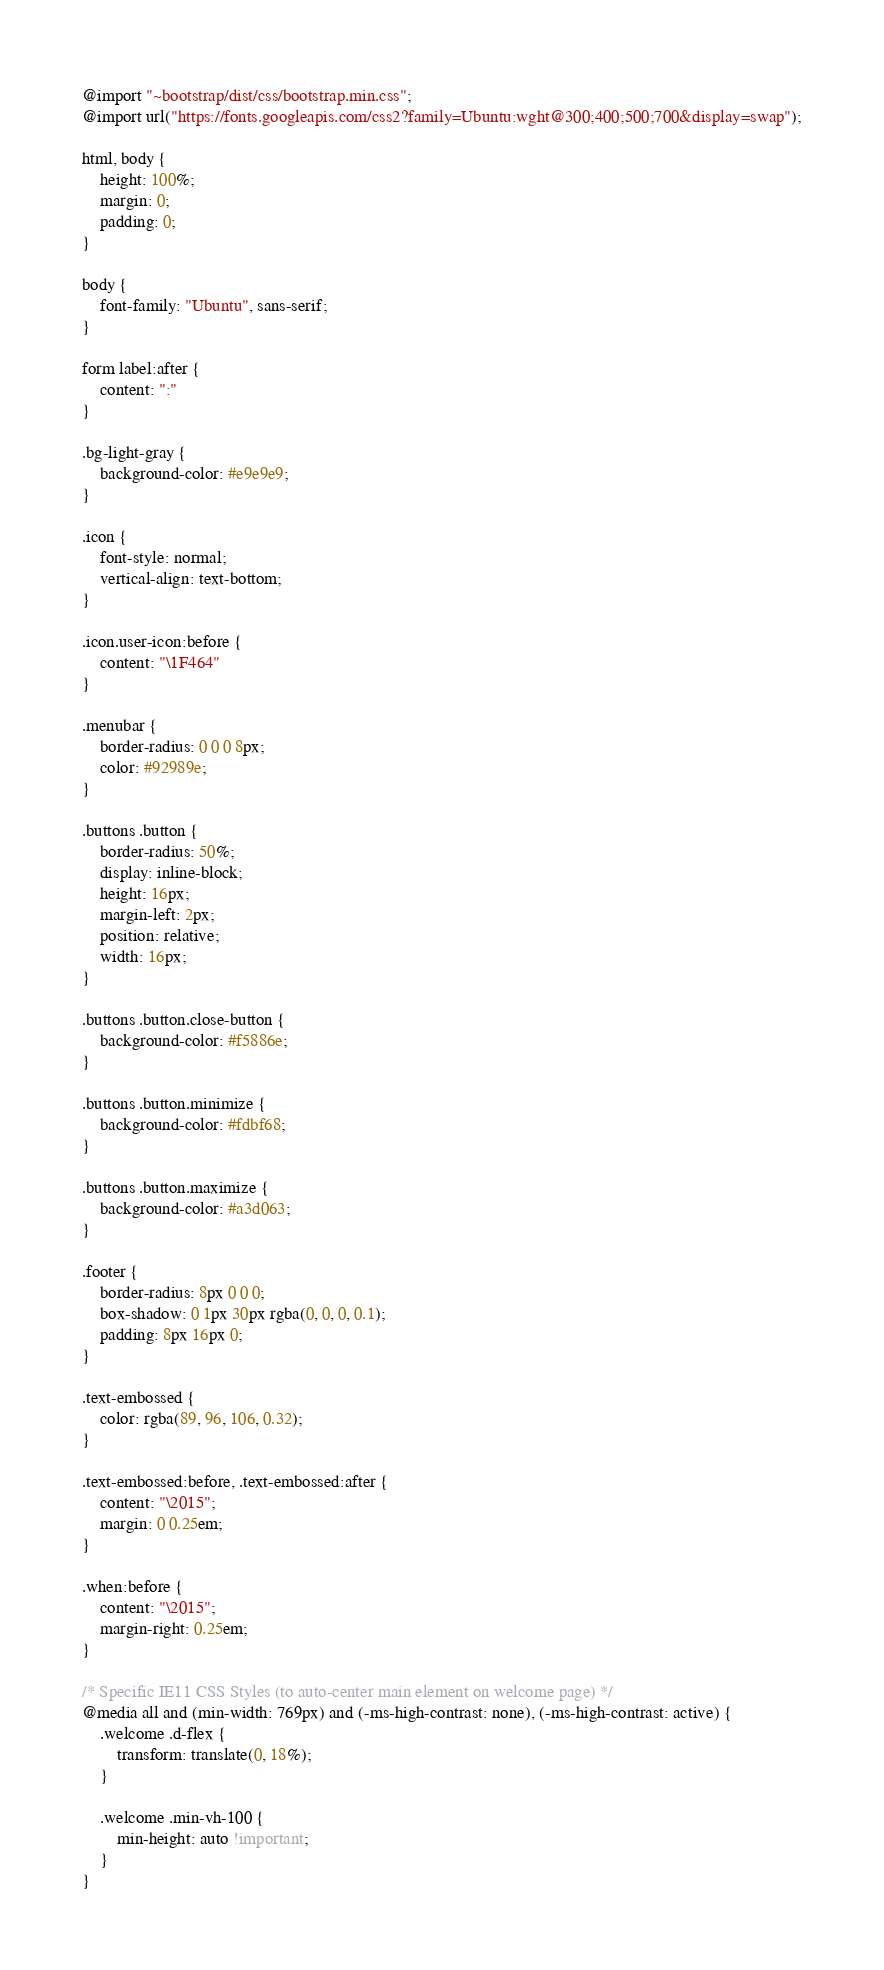<code> <loc_0><loc_0><loc_500><loc_500><_CSS_>@import "~bootstrap/dist/css/bootstrap.min.css";
@import url("https://fonts.googleapis.com/css2?family=Ubuntu:wght@300;400;500;700&display=swap");

html, body {
	height: 100%;
	margin: 0;
	padding: 0;
}

body {
	font-family: "Ubuntu", sans-serif;
}

form label:after {
	content: ":"
}

.bg-light-gray {
	background-color: #e9e9e9;
}

.icon {
	font-style: normal;
	vertical-align: text-bottom;
}

.icon.user-icon:before {
	content: "\1F464"
}

.menubar {
	border-radius: 0 0 0 8px;
	color: #92989e;
}

.buttons .button {
	border-radius: 50%;
	display: inline-block;
	height: 16px;
	margin-left: 2px;
	position: relative;
	width: 16px;
}

.buttons .button.close-button {
	background-color: #f5886e;
}

.buttons .button.minimize {
	background-color: #fdbf68;
}

.buttons .button.maximize {
	background-color: #a3d063;
}

.footer {
	border-radius: 8px 0 0 0;
	box-shadow: 0 1px 30px rgba(0, 0, 0, 0.1);
	padding: 8px 16px 0;
}

.text-embossed {
	color: rgba(89, 96, 106, 0.32);
}

.text-embossed:before, .text-embossed:after {
	content: "\2015";
	margin: 0 0.25em;
}

.when:before {
	content: "\2015";
	margin-right: 0.25em;
}

/* Specific IE11 CSS Styles (to auto-center main element on welcome page) */
@media all and (min-width: 769px) and (-ms-high-contrast: none), (-ms-high-contrast: active) {
	.welcome .d-flex {
		transform: translate(0, 18%);
	}

	.welcome .min-vh-100 {
		min-height: auto !important;
	}
}
</code> 